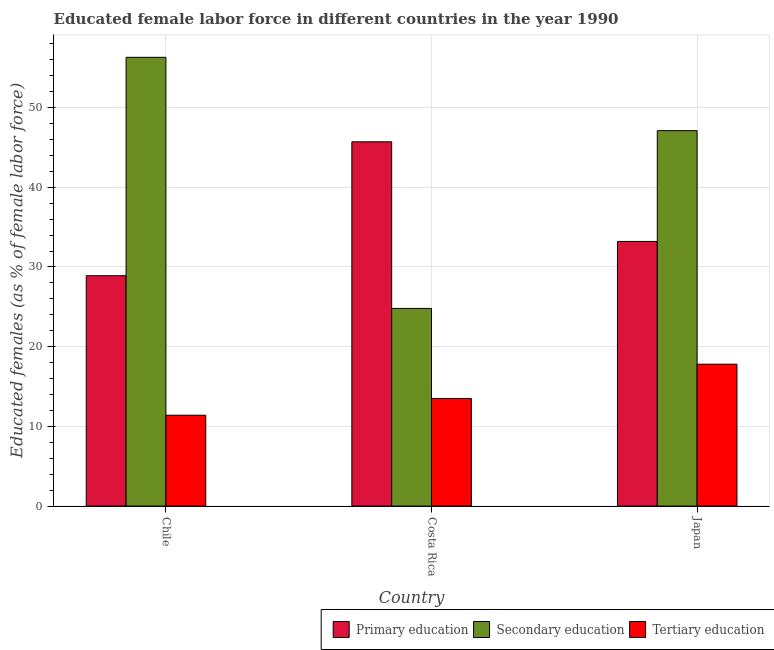Are the number of bars on each tick of the X-axis equal?
Your answer should be very brief. Yes. How many bars are there on the 1st tick from the right?
Make the answer very short. 3. What is the label of the 2nd group of bars from the left?
Your answer should be compact. Costa Rica. What is the percentage of female labor force who received tertiary education in Chile?
Your answer should be very brief. 11.4. Across all countries, what is the maximum percentage of female labor force who received secondary education?
Provide a succinct answer. 56.3. Across all countries, what is the minimum percentage of female labor force who received primary education?
Your answer should be very brief. 28.9. In which country was the percentage of female labor force who received secondary education maximum?
Provide a short and direct response. Chile. In which country was the percentage of female labor force who received secondary education minimum?
Your answer should be compact. Costa Rica. What is the total percentage of female labor force who received secondary education in the graph?
Your response must be concise. 128.2. What is the difference between the percentage of female labor force who received tertiary education in Chile and that in Japan?
Give a very brief answer. -6.4. What is the difference between the percentage of female labor force who received secondary education in Japan and the percentage of female labor force who received primary education in Costa Rica?
Offer a very short reply. 1.4. What is the average percentage of female labor force who received secondary education per country?
Keep it short and to the point. 42.73. What is the difference between the percentage of female labor force who received secondary education and percentage of female labor force who received primary education in Japan?
Ensure brevity in your answer.  13.9. In how many countries, is the percentage of female labor force who received primary education greater than 6 %?
Make the answer very short. 3. What is the ratio of the percentage of female labor force who received secondary education in Costa Rica to that in Japan?
Your response must be concise. 0.53. What is the difference between the highest and the second highest percentage of female labor force who received tertiary education?
Provide a short and direct response. 4.3. What is the difference between the highest and the lowest percentage of female labor force who received tertiary education?
Your response must be concise. 6.4. In how many countries, is the percentage of female labor force who received secondary education greater than the average percentage of female labor force who received secondary education taken over all countries?
Give a very brief answer. 2. Is the sum of the percentage of female labor force who received tertiary education in Chile and Costa Rica greater than the maximum percentage of female labor force who received primary education across all countries?
Offer a terse response. No. What does the 2nd bar from the left in Chile represents?
Offer a terse response. Secondary education. What does the 2nd bar from the right in Japan represents?
Give a very brief answer. Secondary education. Is it the case that in every country, the sum of the percentage of female labor force who received primary education and percentage of female labor force who received secondary education is greater than the percentage of female labor force who received tertiary education?
Give a very brief answer. Yes. How many bars are there?
Provide a succinct answer. 9. Are all the bars in the graph horizontal?
Keep it short and to the point. No. How many countries are there in the graph?
Make the answer very short. 3. What is the difference between two consecutive major ticks on the Y-axis?
Give a very brief answer. 10. Are the values on the major ticks of Y-axis written in scientific E-notation?
Make the answer very short. No. Does the graph contain any zero values?
Offer a very short reply. No. Does the graph contain grids?
Provide a short and direct response. Yes. How are the legend labels stacked?
Keep it short and to the point. Horizontal. What is the title of the graph?
Provide a short and direct response. Educated female labor force in different countries in the year 1990. What is the label or title of the Y-axis?
Your response must be concise. Educated females (as % of female labor force). What is the Educated females (as % of female labor force) of Primary education in Chile?
Ensure brevity in your answer.  28.9. What is the Educated females (as % of female labor force) of Secondary education in Chile?
Your response must be concise. 56.3. What is the Educated females (as % of female labor force) in Tertiary education in Chile?
Ensure brevity in your answer.  11.4. What is the Educated females (as % of female labor force) of Primary education in Costa Rica?
Give a very brief answer. 45.7. What is the Educated females (as % of female labor force) in Secondary education in Costa Rica?
Provide a short and direct response. 24.8. What is the Educated females (as % of female labor force) in Primary education in Japan?
Ensure brevity in your answer.  33.2. What is the Educated females (as % of female labor force) of Secondary education in Japan?
Ensure brevity in your answer.  47.1. What is the Educated females (as % of female labor force) in Tertiary education in Japan?
Give a very brief answer. 17.8. Across all countries, what is the maximum Educated females (as % of female labor force) in Primary education?
Provide a short and direct response. 45.7. Across all countries, what is the maximum Educated females (as % of female labor force) of Secondary education?
Your response must be concise. 56.3. Across all countries, what is the maximum Educated females (as % of female labor force) in Tertiary education?
Your response must be concise. 17.8. Across all countries, what is the minimum Educated females (as % of female labor force) of Primary education?
Make the answer very short. 28.9. Across all countries, what is the minimum Educated females (as % of female labor force) in Secondary education?
Ensure brevity in your answer.  24.8. Across all countries, what is the minimum Educated females (as % of female labor force) in Tertiary education?
Provide a short and direct response. 11.4. What is the total Educated females (as % of female labor force) of Primary education in the graph?
Ensure brevity in your answer.  107.8. What is the total Educated females (as % of female labor force) of Secondary education in the graph?
Offer a terse response. 128.2. What is the total Educated females (as % of female labor force) in Tertiary education in the graph?
Provide a succinct answer. 42.7. What is the difference between the Educated females (as % of female labor force) of Primary education in Chile and that in Costa Rica?
Make the answer very short. -16.8. What is the difference between the Educated females (as % of female labor force) in Secondary education in Chile and that in Costa Rica?
Your response must be concise. 31.5. What is the difference between the Educated females (as % of female labor force) of Tertiary education in Chile and that in Costa Rica?
Your response must be concise. -2.1. What is the difference between the Educated females (as % of female labor force) in Primary education in Chile and that in Japan?
Provide a short and direct response. -4.3. What is the difference between the Educated females (as % of female labor force) of Secondary education in Chile and that in Japan?
Keep it short and to the point. 9.2. What is the difference between the Educated females (as % of female labor force) in Tertiary education in Chile and that in Japan?
Your response must be concise. -6.4. What is the difference between the Educated females (as % of female labor force) of Secondary education in Costa Rica and that in Japan?
Ensure brevity in your answer.  -22.3. What is the difference between the Educated females (as % of female labor force) in Primary education in Chile and the Educated females (as % of female labor force) in Secondary education in Costa Rica?
Ensure brevity in your answer.  4.1. What is the difference between the Educated females (as % of female labor force) of Primary education in Chile and the Educated females (as % of female labor force) of Tertiary education in Costa Rica?
Make the answer very short. 15.4. What is the difference between the Educated females (as % of female labor force) in Secondary education in Chile and the Educated females (as % of female labor force) in Tertiary education in Costa Rica?
Your answer should be compact. 42.8. What is the difference between the Educated females (as % of female labor force) of Primary education in Chile and the Educated females (as % of female labor force) of Secondary education in Japan?
Provide a succinct answer. -18.2. What is the difference between the Educated females (as % of female labor force) in Primary education in Chile and the Educated females (as % of female labor force) in Tertiary education in Japan?
Offer a terse response. 11.1. What is the difference between the Educated females (as % of female labor force) of Secondary education in Chile and the Educated females (as % of female labor force) of Tertiary education in Japan?
Your answer should be compact. 38.5. What is the difference between the Educated females (as % of female labor force) in Primary education in Costa Rica and the Educated females (as % of female labor force) in Secondary education in Japan?
Offer a very short reply. -1.4. What is the difference between the Educated females (as % of female labor force) in Primary education in Costa Rica and the Educated females (as % of female labor force) in Tertiary education in Japan?
Ensure brevity in your answer.  27.9. What is the difference between the Educated females (as % of female labor force) in Secondary education in Costa Rica and the Educated females (as % of female labor force) in Tertiary education in Japan?
Give a very brief answer. 7. What is the average Educated females (as % of female labor force) in Primary education per country?
Offer a terse response. 35.93. What is the average Educated females (as % of female labor force) of Secondary education per country?
Your answer should be compact. 42.73. What is the average Educated females (as % of female labor force) of Tertiary education per country?
Give a very brief answer. 14.23. What is the difference between the Educated females (as % of female labor force) in Primary education and Educated females (as % of female labor force) in Secondary education in Chile?
Offer a very short reply. -27.4. What is the difference between the Educated females (as % of female labor force) of Primary education and Educated females (as % of female labor force) of Tertiary education in Chile?
Ensure brevity in your answer.  17.5. What is the difference between the Educated females (as % of female labor force) of Secondary education and Educated females (as % of female labor force) of Tertiary education in Chile?
Give a very brief answer. 44.9. What is the difference between the Educated females (as % of female labor force) in Primary education and Educated females (as % of female labor force) in Secondary education in Costa Rica?
Your response must be concise. 20.9. What is the difference between the Educated females (as % of female labor force) of Primary education and Educated females (as % of female labor force) of Tertiary education in Costa Rica?
Your response must be concise. 32.2. What is the difference between the Educated females (as % of female labor force) in Secondary education and Educated females (as % of female labor force) in Tertiary education in Japan?
Keep it short and to the point. 29.3. What is the ratio of the Educated females (as % of female labor force) of Primary education in Chile to that in Costa Rica?
Your answer should be compact. 0.63. What is the ratio of the Educated females (as % of female labor force) of Secondary education in Chile to that in Costa Rica?
Your answer should be compact. 2.27. What is the ratio of the Educated females (as % of female labor force) of Tertiary education in Chile to that in Costa Rica?
Make the answer very short. 0.84. What is the ratio of the Educated females (as % of female labor force) in Primary education in Chile to that in Japan?
Keep it short and to the point. 0.87. What is the ratio of the Educated females (as % of female labor force) of Secondary education in Chile to that in Japan?
Provide a succinct answer. 1.2. What is the ratio of the Educated females (as % of female labor force) of Tertiary education in Chile to that in Japan?
Your answer should be very brief. 0.64. What is the ratio of the Educated females (as % of female labor force) in Primary education in Costa Rica to that in Japan?
Keep it short and to the point. 1.38. What is the ratio of the Educated females (as % of female labor force) of Secondary education in Costa Rica to that in Japan?
Provide a succinct answer. 0.53. What is the ratio of the Educated females (as % of female labor force) of Tertiary education in Costa Rica to that in Japan?
Ensure brevity in your answer.  0.76. What is the difference between the highest and the lowest Educated females (as % of female labor force) of Primary education?
Offer a very short reply. 16.8. What is the difference between the highest and the lowest Educated females (as % of female labor force) in Secondary education?
Ensure brevity in your answer.  31.5. 